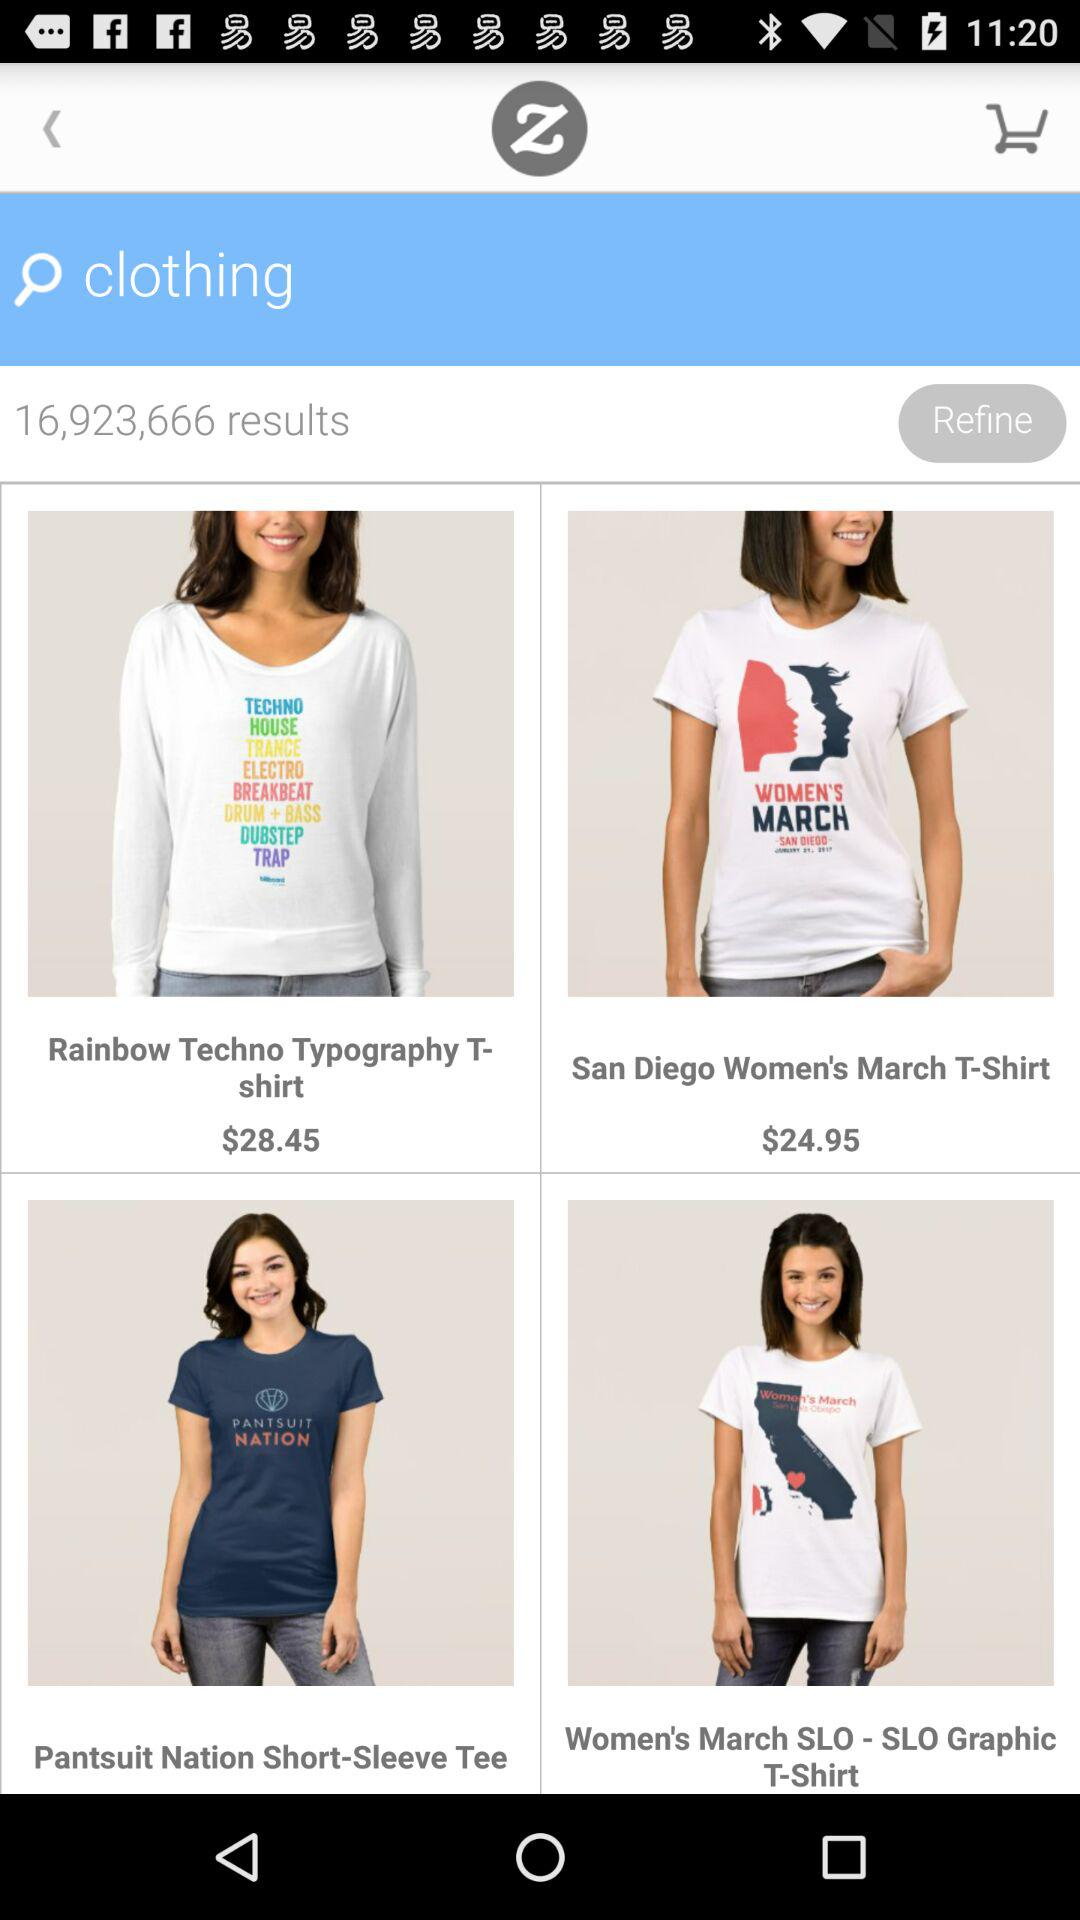What item is the person searching for? The person is searching for "clothing". 